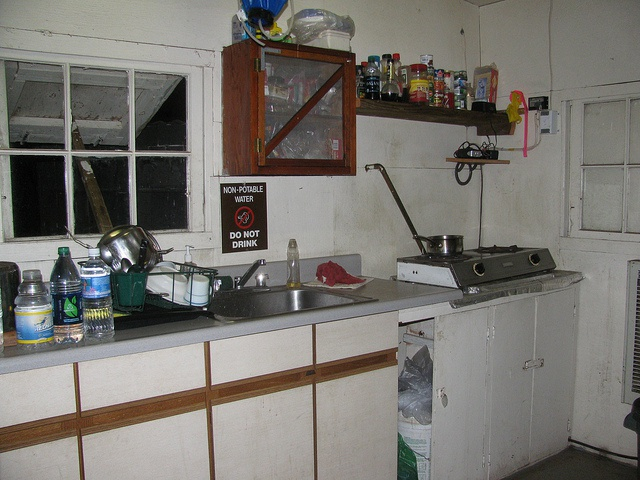Describe the objects in this image and their specific colors. I can see oven in gray, black, and darkgray tones, sink in gray and black tones, bottle in gray, black, teal, and navy tones, bottle in gray, darkgray, and lightgray tones, and bottle in gray, black, darkgray, and white tones in this image. 